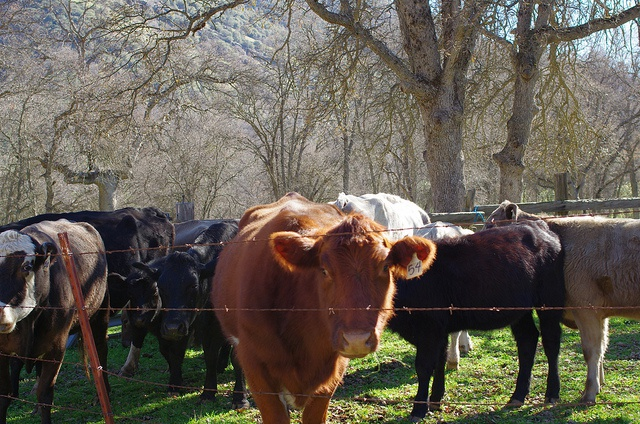Describe the objects in this image and their specific colors. I can see cow in gray, maroon, black, brown, and tan tones, cow in gray, black, maroon, and darkgray tones, cow in gray, black, maroon, and darkgray tones, cow in gray and black tones, and cow in gray, black, and maroon tones in this image. 